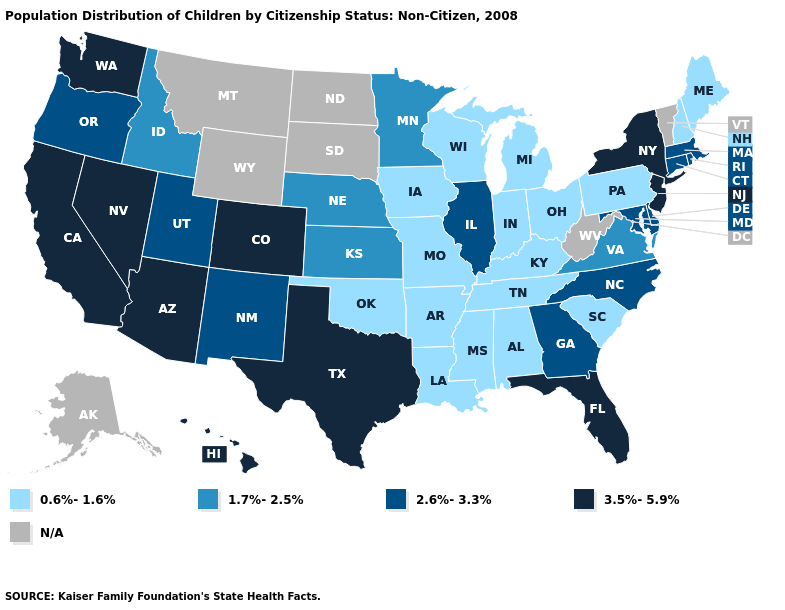What is the value of Virginia?
Quick response, please. 1.7%-2.5%. Name the states that have a value in the range 1.7%-2.5%?
Short answer required. Idaho, Kansas, Minnesota, Nebraska, Virginia. What is the value of North Carolina?
Keep it brief. 2.6%-3.3%. Is the legend a continuous bar?
Write a very short answer. No. What is the value of Hawaii?
Keep it brief. 3.5%-5.9%. What is the lowest value in the USA?
Short answer required. 0.6%-1.6%. What is the value of Nevada?
Keep it brief. 3.5%-5.9%. Name the states that have a value in the range 2.6%-3.3%?
Quick response, please. Connecticut, Delaware, Georgia, Illinois, Maryland, Massachusetts, New Mexico, North Carolina, Oregon, Rhode Island, Utah. Name the states that have a value in the range 2.6%-3.3%?
Concise answer only. Connecticut, Delaware, Georgia, Illinois, Maryland, Massachusetts, New Mexico, North Carolina, Oregon, Rhode Island, Utah. Name the states that have a value in the range 0.6%-1.6%?
Keep it brief. Alabama, Arkansas, Indiana, Iowa, Kentucky, Louisiana, Maine, Michigan, Mississippi, Missouri, New Hampshire, Ohio, Oklahoma, Pennsylvania, South Carolina, Tennessee, Wisconsin. Among the states that border Washington , does Idaho have the lowest value?
Be succinct. Yes. What is the value of Wisconsin?
Answer briefly. 0.6%-1.6%. 